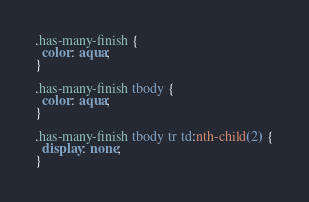<code> <loc_0><loc_0><loc_500><loc_500><_CSS_>.has-many-finish {
  color: aqua;
}

.has-many-finish tbody {
  color: aqua;
}

.has-many-finish tbody tr td:nth-child(2) {
  display: none;
}

</code> 